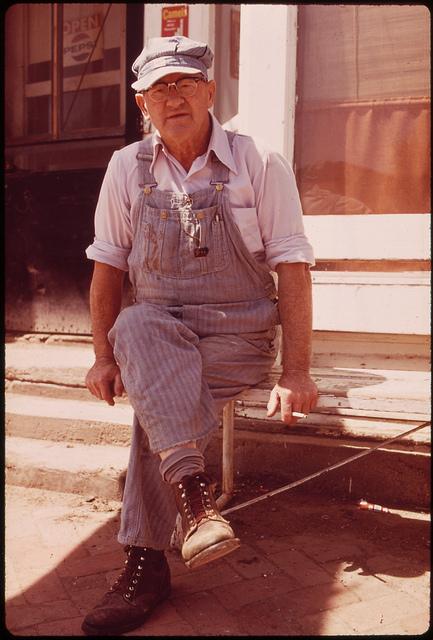Is the background blurry?
Write a very short answer. No. How many steps are there?
Be succinct. 3. How can you tell this picture is vintage?
Keep it brief. Clothing. What is hanging from the mens' necks?
Be succinct. Wrinkles. What is the man wearing?
Concise answer only. Overalls. Where is the man sitting?
Keep it brief. Bench. What color is the photo?
Be succinct. Sepia. Is the man smiling?
Concise answer only. No. 